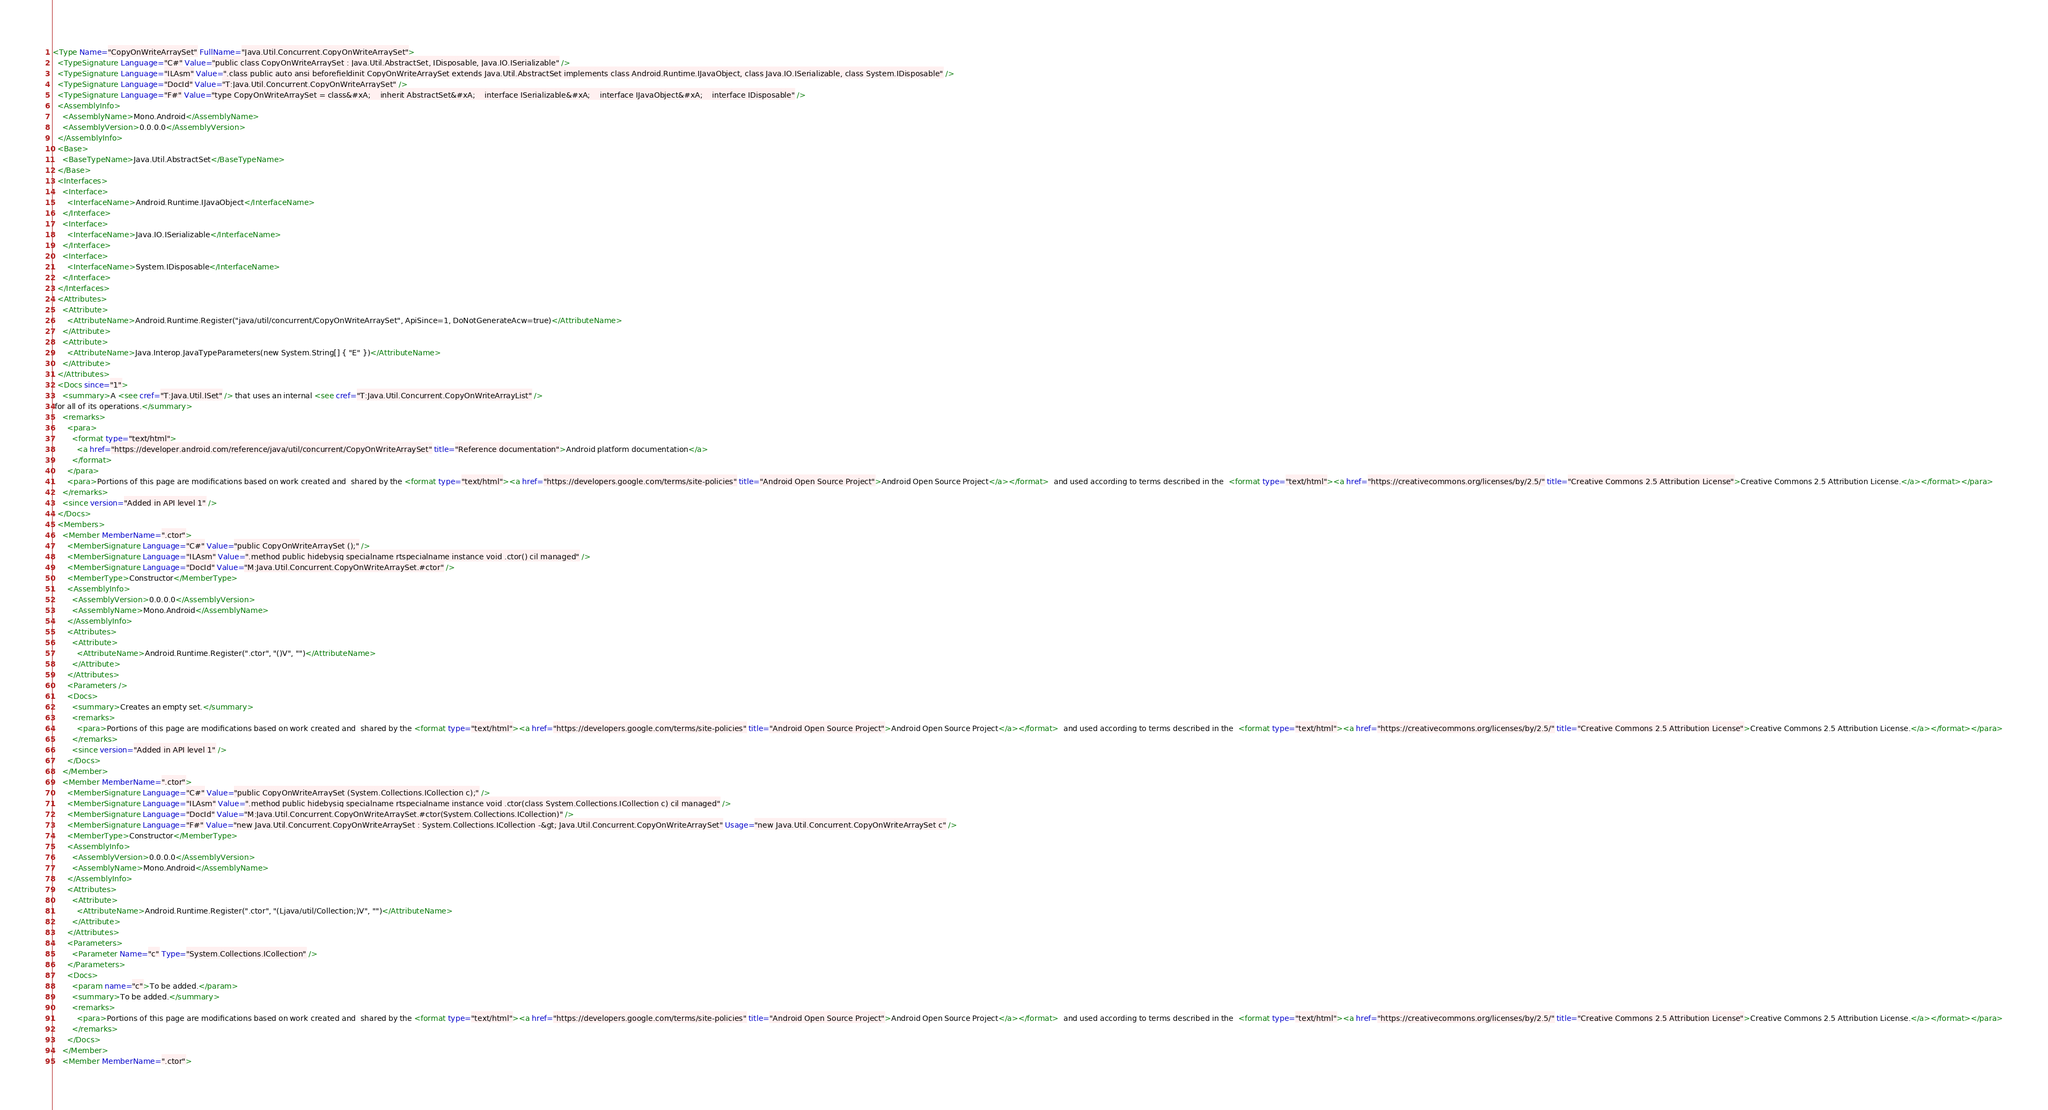<code> <loc_0><loc_0><loc_500><loc_500><_XML_><Type Name="CopyOnWriteArraySet" FullName="Java.Util.Concurrent.CopyOnWriteArraySet">
  <TypeSignature Language="C#" Value="public class CopyOnWriteArraySet : Java.Util.AbstractSet, IDisposable, Java.IO.ISerializable" />
  <TypeSignature Language="ILAsm" Value=".class public auto ansi beforefieldinit CopyOnWriteArraySet extends Java.Util.AbstractSet implements class Android.Runtime.IJavaObject, class Java.IO.ISerializable, class System.IDisposable" />
  <TypeSignature Language="DocId" Value="T:Java.Util.Concurrent.CopyOnWriteArraySet" />
  <TypeSignature Language="F#" Value="type CopyOnWriteArraySet = class&#xA;    inherit AbstractSet&#xA;    interface ISerializable&#xA;    interface IJavaObject&#xA;    interface IDisposable" />
  <AssemblyInfo>
    <AssemblyName>Mono.Android</AssemblyName>
    <AssemblyVersion>0.0.0.0</AssemblyVersion>
  </AssemblyInfo>
  <Base>
    <BaseTypeName>Java.Util.AbstractSet</BaseTypeName>
  </Base>
  <Interfaces>
    <Interface>
      <InterfaceName>Android.Runtime.IJavaObject</InterfaceName>
    </Interface>
    <Interface>
      <InterfaceName>Java.IO.ISerializable</InterfaceName>
    </Interface>
    <Interface>
      <InterfaceName>System.IDisposable</InterfaceName>
    </Interface>
  </Interfaces>
  <Attributes>
    <Attribute>
      <AttributeName>Android.Runtime.Register("java/util/concurrent/CopyOnWriteArraySet", ApiSince=1, DoNotGenerateAcw=true)</AttributeName>
    </Attribute>
    <Attribute>
      <AttributeName>Java.Interop.JavaTypeParameters(new System.String[] { "E" })</AttributeName>
    </Attribute>
  </Attributes>
  <Docs since="1">
    <summary>A <see cref="T:Java.Util.ISet" /> that uses an internal <see cref="T:Java.Util.Concurrent.CopyOnWriteArrayList" />
 for all of its operations.</summary>
    <remarks>
      <para>
        <format type="text/html">
          <a href="https://developer.android.com/reference/java/util/concurrent/CopyOnWriteArraySet" title="Reference documentation">Android platform documentation</a>
        </format>
      </para>
      <para>Portions of this page are modifications based on work created and shared by the <format type="text/html"><a href="https://developers.google.com/terms/site-policies" title="Android Open Source Project">Android Open Source Project</a></format> and used according to terms described in the <format type="text/html"><a href="https://creativecommons.org/licenses/by/2.5/" title="Creative Commons 2.5 Attribution License">Creative Commons 2.5 Attribution License.</a></format></para>
    </remarks>
    <since version="Added in API level 1" />
  </Docs>
  <Members>
    <Member MemberName=".ctor">
      <MemberSignature Language="C#" Value="public CopyOnWriteArraySet ();" />
      <MemberSignature Language="ILAsm" Value=".method public hidebysig specialname rtspecialname instance void .ctor() cil managed" />
      <MemberSignature Language="DocId" Value="M:Java.Util.Concurrent.CopyOnWriteArraySet.#ctor" />
      <MemberType>Constructor</MemberType>
      <AssemblyInfo>
        <AssemblyVersion>0.0.0.0</AssemblyVersion>
        <AssemblyName>Mono.Android</AssemblyName>
      </AssemblyInfo>
      <Attributes>
        <Attribute>
          <AttributeName>Android.Runtime.Register(".ctor", "()V", "")</AttributeName>
        </Attribute>
      </Attributes>
      <Parameters />
      <Docs>
        <summary>Creates an empty set.</summary>
        <remarks>
          <para>Portions of this page are modifications based on work created and shared by the <format type="text/html"><a href="https://developers.google.com/terms/site-policies" title="Android Open Source Project">Android Open Source Project</a></format> and used according to terms described in the <format type="text/html"><a href="https://creativecommons.org/licenses/by/2.5/" title="Creative Commons 2.5 Attribution License">Creative Commons 2.5 Attribution License.</a></format></para>
        </remarks>
        <since version="Added in API level 1" />
      </Docs>
    </Member>
    <Member MemberName=".ctor">
      <MemberSignature Language="C#" Value="public CopyOnWriteArraySet (System.Collections.ICollection c);" />
      <MemberSignature Language="ILAsm" Value=".method public hidebysig specialname rtspecialname instance void .ctor(class System.Collections.ICollection c) cil managed" />
      <MemberSignature Language="DocId" Value="M:Java.Util.Concurrent.CopyOnWriteArraySet.#ctor(System.Collections.ICollection)" />
      <MemberSignature Language="F#" Value="new Java.Util.Concurrent.CopyOnWriteArraySet : System.Collections.ICollection -&gt; Java.Util.Concurrent.CopyOnWriteArraySet" Usage="new Java.Util.Concurrent.CopyOnWriteArraySet c" />
      <MemberType>Constructor</MemberType>
      <AssemblyInfo>
        <AssemblyVersion>0.0.0.0</AssemblyVersion>
        <AssemblyName>Mono.Android</AssemblyName>
      </AssemblyInfo>
      <Attributes>
        <Attribute>
          <AttributeName>Android.Runtime.Register(".ctor", "(Ljava/util/Collection;)V", "")</AttributeName>
        </Attribute>
      </Attributes>
      <Parameters>
        <Parameter Name="c" Type="System.Collections.ICollection" />
      </Parameters>
      <Docs>
        <param name="c">To be added.</param>
        <summary>To be added.</summary>
        <remarks>
          <para>Portions of this page are modifications based on work created and shared by the <format type="text/html"><a href="https://developers.google.com/terms/site-policies" title="Android Open Source Project">Android Open Source Project</a></format> and used according to terms described in the <format type="text/html"><a href="https://creativecommons.org/licenses/by/2.5/" title="Creative Commons 2.5 Attribution License">Creative Commons 2.5 Attribution License.</a></format></para>
        </remarks>
      </Docs>
    </Member>
    <Member MemberName=".ctor"></code> 